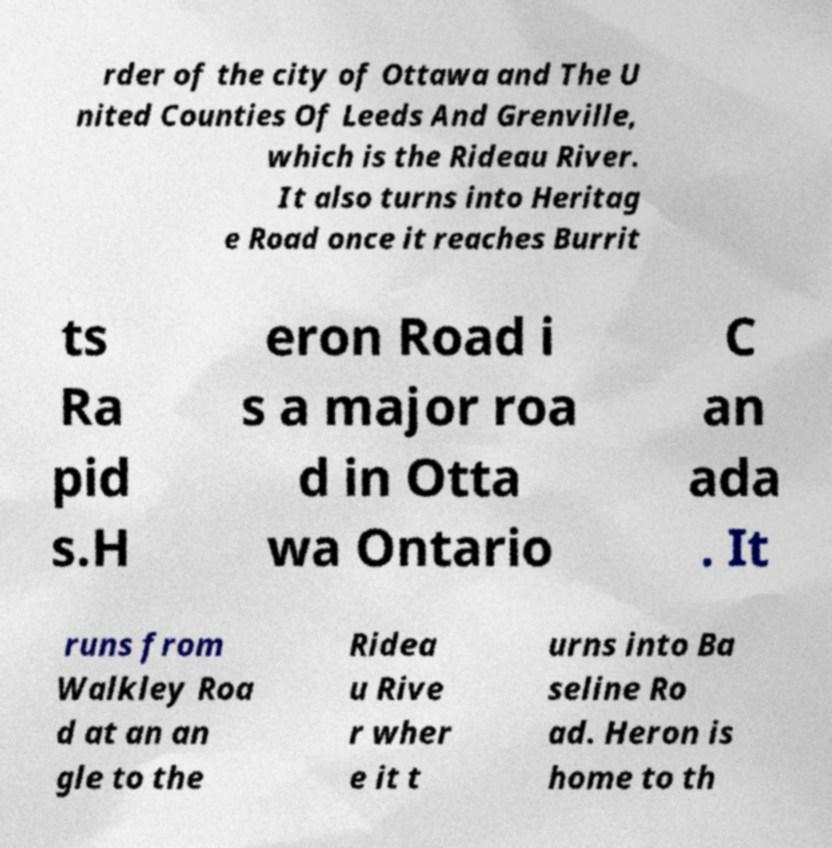Could you assist in decoding the text presented in this image and type it out clearly? rder of the city of Ottawa and The U nited Counties Of Leeds And Grenville, which is the Rideau River. It also turns into Heritag e Road once it reaches Burrit ts Ra pid s.H eron Road i s a major roa d in Otta wa Ontario C an ada . It runs from Walkley Roa d at an an gle to the Ridea u Rive r wher e it t urns into Ba seline Ro ad. Heron is home to th 